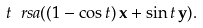Convert formula to latex. <formula><loc_0><loc_0><loc_500><loc_500>t \ r s a ( ( 1 - \cos t ) \, \mathbf x + \sin t \, \mathbf y ) .</formula> 